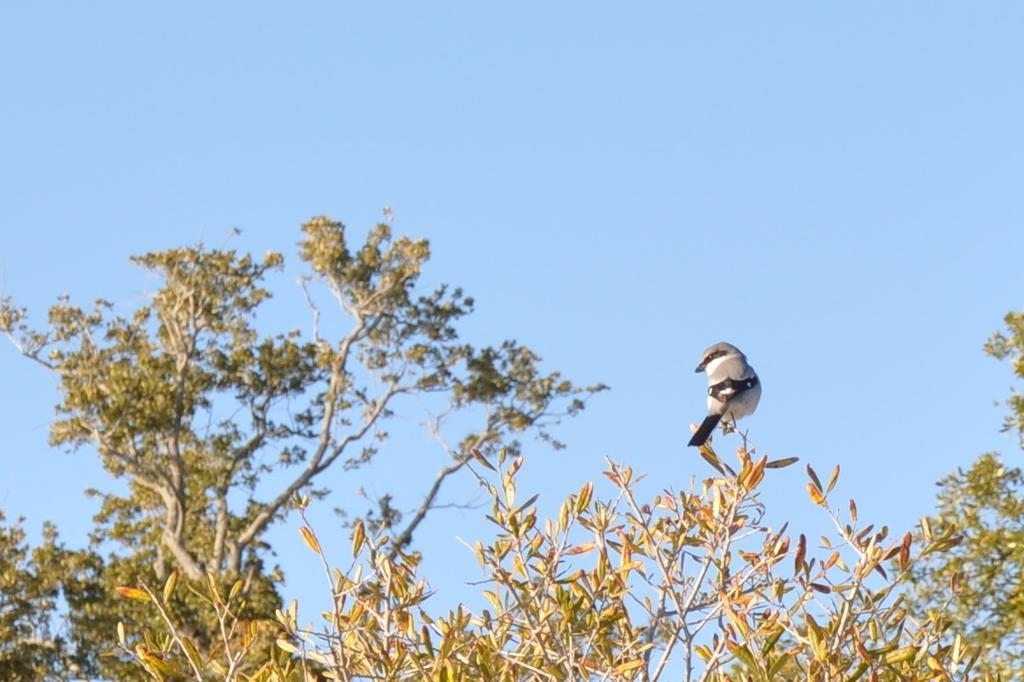What type of animal can be seen in the picture? There is a bird in the picture. Where is the bird located? The bird is standing on a tree. How many trees are visible in the picture? There are three trees visible in the picture, with the bird on one of them and another tree on either side. What type of powder is being used by the queen in the image? There is no queen or powder present in the image; it features a bird standing on a tree. 